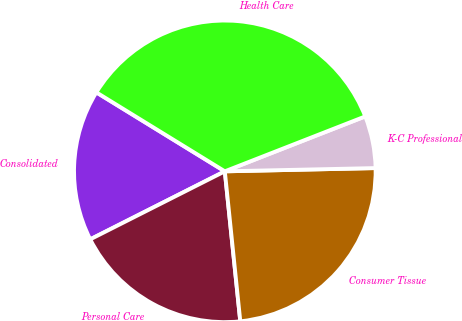<chart> <loc_0><loc_0><loc_500><loc_500><pie_chart><fcel>Consolidated<fcel>Personal Care<fcel>Consumer Tissue<fcel>K-C Professional<fcel>Health Care<nl><fcel>16.22%<fcel>19.19%<fcel>23.71%<fcel>5.59%<fcel>35.3%<nl></chart> 